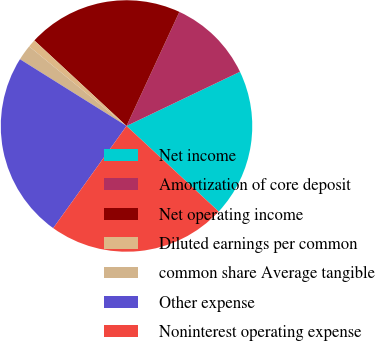<chart> <loc_0><loc_0><loc_500><loc_500><pie_chart><fcel>Net income<fcel>Amortization of core deposit<fcel>Net operating income<fcel>Diluted earnings per common<fcel>common share Average tangible<fcel>Other expense<fcel>Noninterest operating expense<nl><fcel>19.0%<fcel>11.0%<fcel>20.0%<fcel>1.0%<fcel>2.0%<fcel>24.0%<fcel>23.0%<nl></chart> 